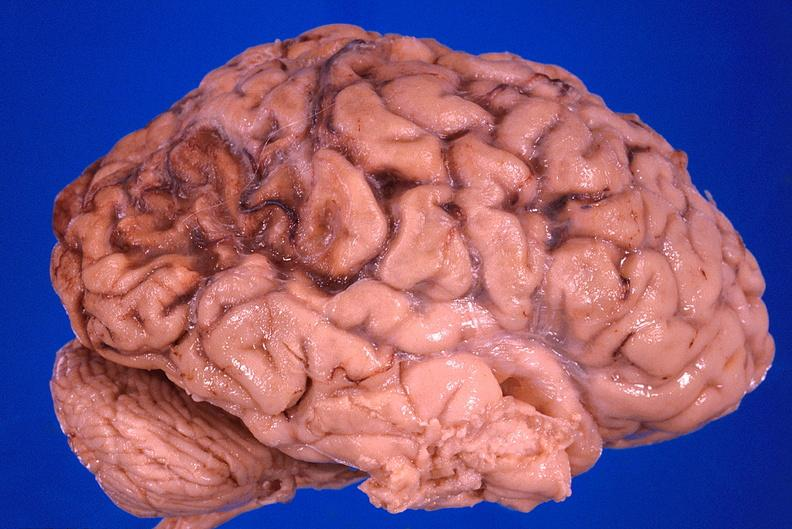s supernumerary digit present?
Answer the question using a single word or phrase. No 